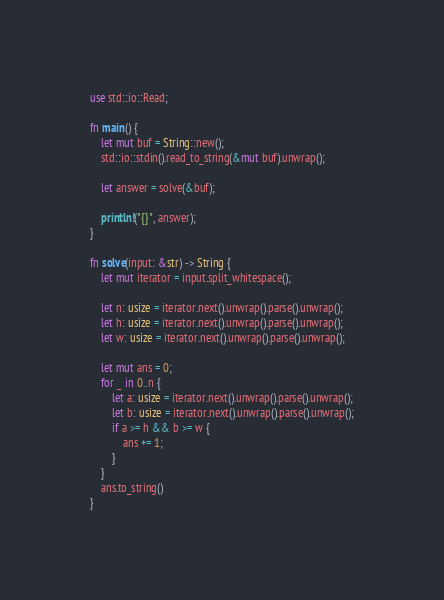<code> <loc_0><loc_0><loc_500><loc_500><_Rust_>use std::io::Read;

fn main() {
    let mut buf = String::new();
    std::io::stdin().read_to_string(&mut buf).unwrap();

    let answer = solve(&buf);

    println!("{}", answer);
}

fn solve(input: &str) -> String {
    let mut iterator = input.split_whitespace();

    let n: usize = iterator.next().unwrap().parse().unwrap();
    let h: usize = iterator.next().unwrap().parse().unwrap();
    let w: usize = iterator.next().unwrap().parse().unwrap();

    let mut ans = 0;
    for _ in 0..n {
        let a: usize = iterator.next().unwrap().parse().unwrap();
        let b: usize = iterator.next().unwrap().parse().unwrap();
        if a >= h && b >= w {
            ans += 1;
        }
    }
    ans.to_string()
}
</code> 